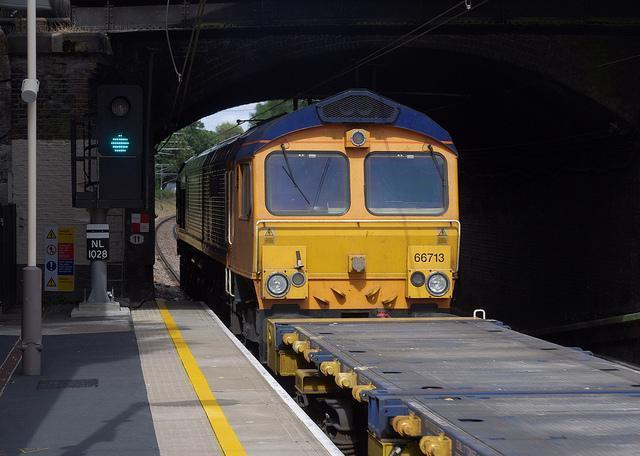How many trains?
Give a very brief answer. 1. How many traffic lights are in the picture?
Give a very brief answer. 1. 